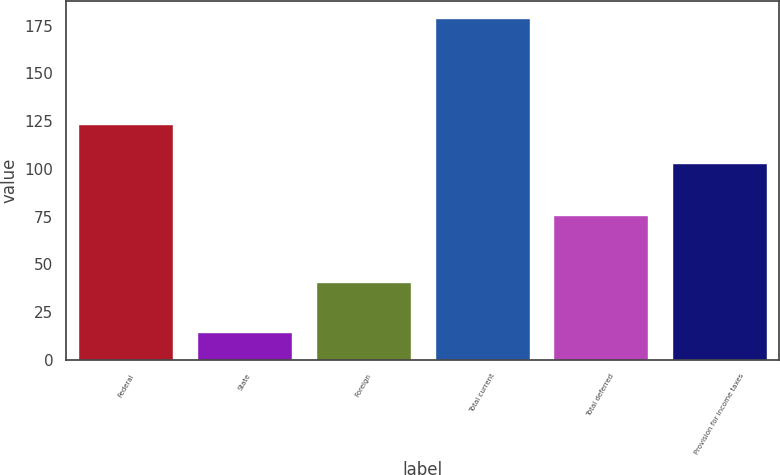<chart> <loc_0><loc_0><loc_500><loc_500><bar_chart><fcel>Federal<fcel>State<fcel>Foreign<fcel>Total current<fcel>Total deferred<fcel>Provision for income taxes<nl><fcel>123.7<fcel>14.6<fcel>40.9<fcel>179.2<fcel>76<fcel>103.2<nl></chart> 